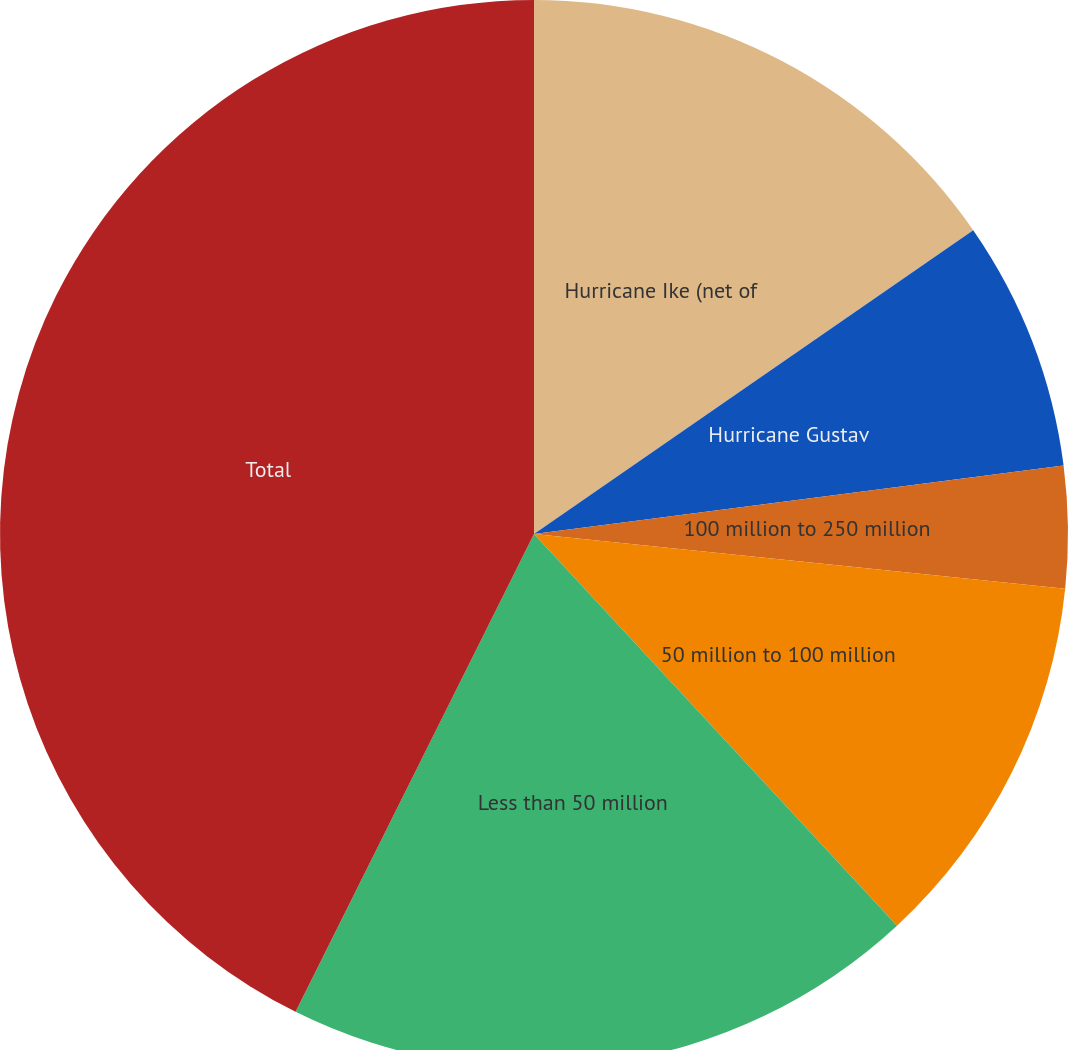Convert chart. <chart><loc_0><loc_0><loc_500><loc_500><pie_chart><fcel>Hurricane Ike (net of<fcel>Hurricane Gustav<fcel>100 million to 250 million<fcel>50 million to 100 million<fcel>Less than 50 million<fcel>Total<nl><fcel>15.37%<fcel>7.58%<fcel>3.68%<fcel>11.47%<fcel>19.26%<fcel>42.63%<nl></chart> 